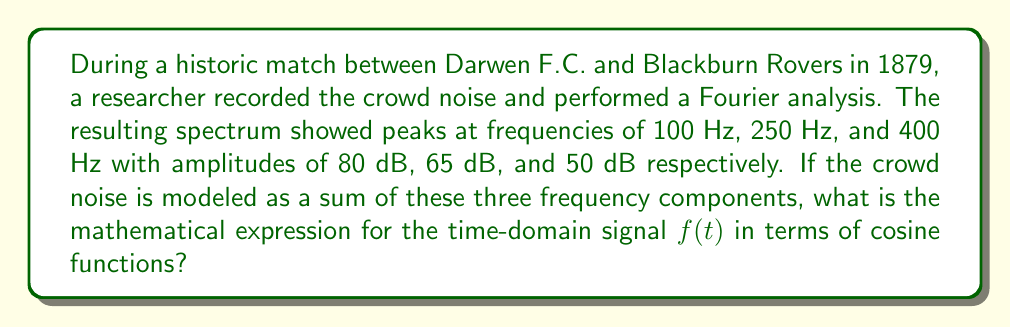What is the answer to this math problem? To solve this problem, we need to understand that the Fourier spectrum represents the frequency components of a signal. Each peak in the spectrum corresponds to a cosine wave in the time domain. We'll construct the signal using the following steps:

1. The general form of a cosine wave is:
   $A \cos(2\pi ft + \phi)$
   where $A$ is the amplitude, $f$ is the frequency, and $\phi$ is the phase shift.

2. We have three frequency components: 100 Hz, 250 Hz, and 400 Hz.

3. The amplitudes are given in decibels (dB). We need to convert these to linear scale using the formula:
   $A = 10^{(dB/20)}$

   For 80 dB: $A_1 = 10^{(80/20)} = 10^4 = 10000$
   For 65 dB: $A_2 = 10^{(65/20)} \approx 1778.28$
   For 50 dB: $A_3 = 10^{(50/20)} = 316.23$

4. Assuming all phase shifts are zero for simplicity, we can now construct the signal as a sum of these three components:

   $f(t) = A_1 \cos(2\pi f_1 t) + A_2 \cos(2\pi f_2 t) + A_3 \cos(2\pi f_3 t)$

5. Substituting the values:

   $f(t) = 10000 \cos(2\pi \cdot 100t) + 1778.28 \cos(2\pi \cdot 250t) + 316.23 \cos(2\pi \cdot 400t)$

This expression represents the time-domain signal of the crowd noise based on the given Fourier analysis.
Answer: $$f(t) = 10000 \cos(200\pi t) + 1778.28 \cos(500\pi t) + 316.23 \cos(800\pi t)$$ 